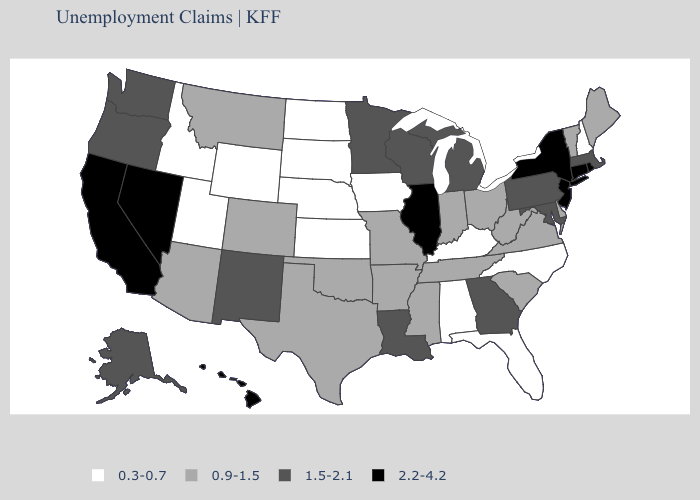Among the states that border Florida , which have the lowest value?
Quick response, please. Alabama. What is the lowest value in the Northeast?
Write a very short answer. 0.3-0.7. How many symbols are there in the legend?
Short answer required. 4. Does North Carolina have the same value as Indiana?
Concise answer only. No. Name the states that have a value in the range 0.3-0.7?
Give a very brief answer. Alabama, Florida, Idaho, Iowa, Kansas, Kentucky, Nebraska, New Hampshire, North Carolina, North Dakota, South Dakota, Utah, Wyoming. Does Vermont have the highest value in the USA?
Be succinct. No. Name the states that have a value in the range 0.9-1.5?
Write a very short answer. Arizona, Arkansas, Colorado, Delaware, Indiana, Maine, Mississippi, Missouri, Montana, Ohio, Oklahoma, South Carolina, Tennessee, Texas, Vermont, Virginia, West Virginia. Does North Carolina have a lower value than Iowa?
Be succinct. No. Name the states that have a value in the range 0.3-0.7?
Give a very brief answer. Alabama, Florida, Idaho, Iowa, Kansas, Kentucky, Nebraska, New Hampshire, North Carolina, North Dakota, South Dakota, Utah, Wyoming. Does Alaska have a lower value than Wisconsin?
Answer briefly. No. Is the legend a continuous bar?
Answer briefly. No. What is the value of Arizona?
Answer briefly. 0.9-1.5. What is the value of South Dakota?
Be succinct. 0.3-0.7. What is the lowest value in the USA?
Keep it brief. 0.3-0.7. Does the map have missing data?
Keep it brief. No. 